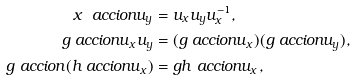<formula> <loc_0><loc_0><loc_500><loc_500>x \ a c c i o n u _ { y } & = u _ { x } u _ { y } u _ { x } ^ { - 1 } , \\ g \ a c c i o n u _ { x } u _ { y } & = ( g \ a c c i o n u _ { x } ) ( g \ a c c i o n u _ { y } ) , \\ g \ a c c i o n ( h \ a c c i o n u _ { x } ) & = g h \ a c c i o n u _ { x } ,</formula> 